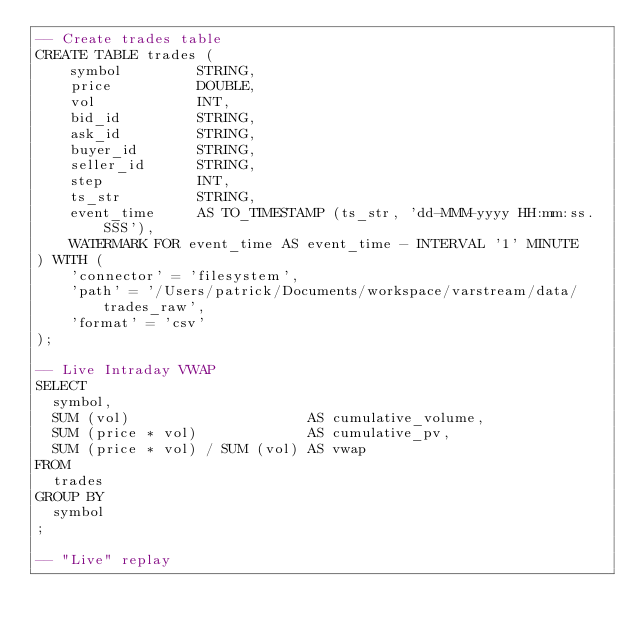Convert code to text. <code><loc_0><loc_0><loc_500><loc_500><_SQL_>-- Create trades table
CREATE TABLE trades (
    symbol         STRING,
    price          DOUBLE,
    vol            INT,
    bid_id         STRING,
    ask_id         STRING,
    buyer_id       STRING,
    seller_id      STRING,
    step           INT,
    ts_str         STRING,
    event_time     AS TO_TIMESTAMP (ts_str, 'dd-MMM-yyyy HH:mm:ss.SSS'),
    WATERMARK FOR event_time AS event_time - INTERVAL '1' MINUTE
) WITH (
    'connector' = 'filesystem',
    'path' = '/Users/patrick/Documents/workspace/varstream/data/trades_raw',
    'format' = 'csv'
);

-- Live Intraday VWAP
SELECT
  symbol,
  SUM (vol)                     AS cumulative_volume,
  SUM (price * vol)             AS cumulative_pv,
  SUM (price * vol) / SUM (vol) AS vwap
FROM
  trades
GROUP BY
  symbol
;

-- "Live" replay</code> 